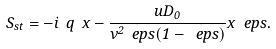Convert formula to latex. <formula><loc_0><loc_0><loc_500><loc_500>S _ { s t } = - i \ q \ x - \frac { u D _ { 0 } } { \nu ^ { 2 } \ e p s ( 1 - \ e p s ) } x ^ { \ } e p s .</formula> 